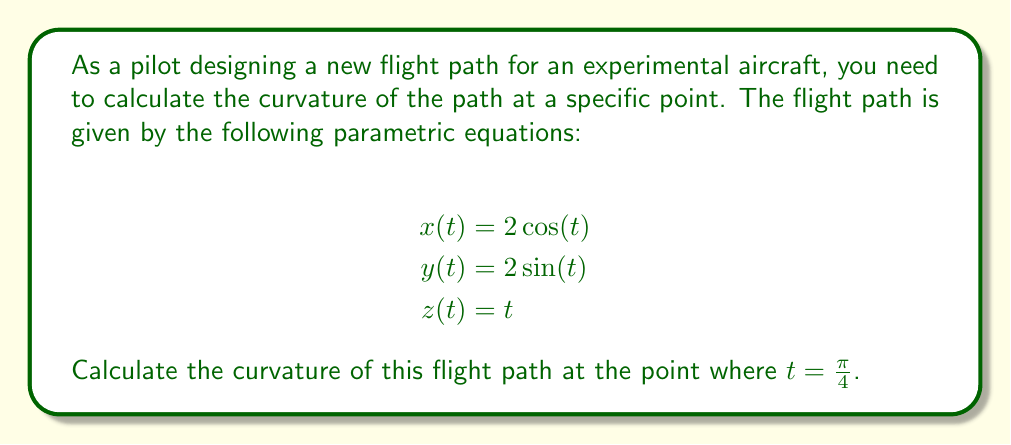What is the answer to this math problem? To calculate the curvature of a three-dimensional parametric curve, we use the formula:

$$\kappa = \frac{\sqrt{||\mathbf{r}'(t) \times \mathbf{r}''(t)||^2}}{||\mathbf{r}'(t)||^3}$$

Where $\mathbf{r}(t) = (x(t), y(t), z(t))$ is the position vector.

Step 1: Calculate $\mathbf{r}'(t)$ and $\mathbf{r}''(t)$

$\mathbf{r}'(t) = (-2\sin(t), 2\cos(t), 1)$
$\mathbf{r}''(t) = (-2\cos(t), -2\sin(t), 0)$

Step 2: Calculate the cross product $\mathbf{r}'(t) \times \mathbf{r}''(t)$

$\mathbf{r}'(t) \times \mathbf{r}''(t) = (2\sin(t), -2\cos(t), 4)$

Step 3: Calculate $||\mathbf{r}'(t) \times \mathbf{r}''(t)||^2$

$||\mathbf{r}'(t) \times \mathbf{r}''(t)||^2 = 4\sin^2(t) + 4\cos^2(t) + 16 = 20$

Step 4: Calculate $||\mathbf{r}'(t)||^3$

$||\mathbf{r}'(t)||^2 = 4\sin^2(t) + 4\cos^2(t) + 1 = 5$
$||\mathbf{r}'(t)||^3 = 5^{3/2}$

Step 5: Apply the curvature formula

$$\kappa = \frac{\sqrt{20}}{5^{3/2}} = \frac{2\sqrt{5}}{5^{3/2}} = \frac{2}{5}$$

This result is constant for all $t$, including $t = \frac{\pi}{4}$.
Answer: The curvature of the flight path at $t = \frac{\pi}{4}$ is $\frac{2}{5}$. 